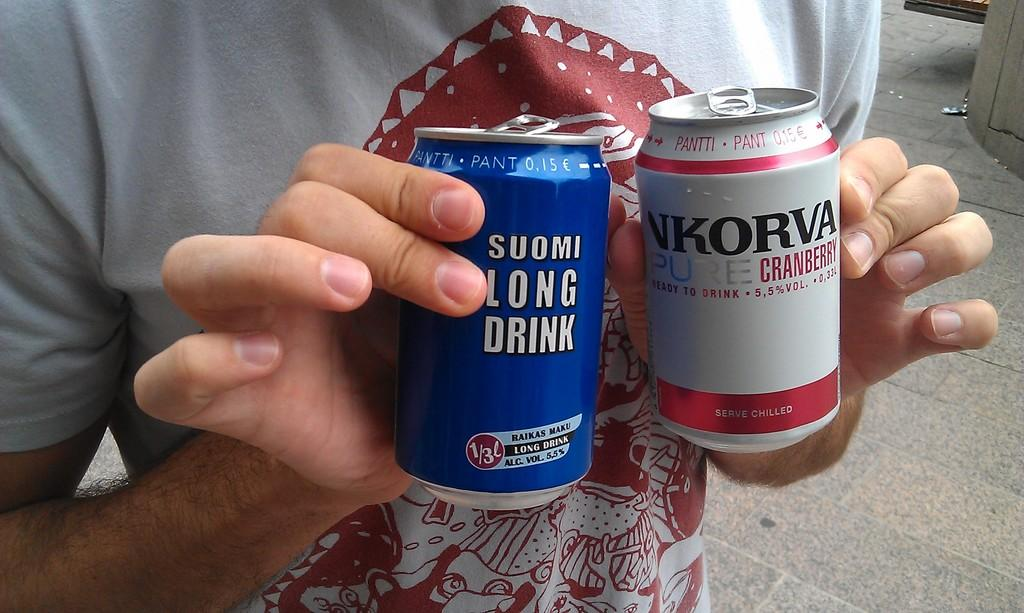<image>
Provide a brief description of the given image. A person is holding two beer cans that say Suomi Long Drink and NKorva Pure Cranberry. 